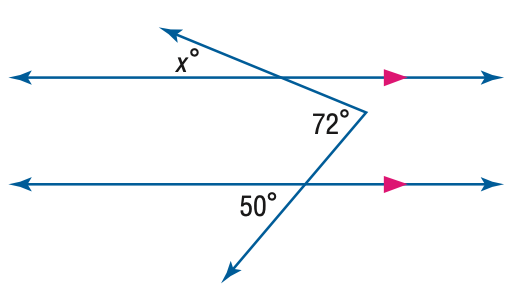Question: Find x. (Hint: Draw an auxiliary line).
Choices:
A. 22
B. 36
C. 50
D. 72
Answer with the letter. Answer: A 